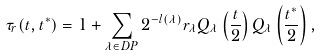Convert formula to latex. <formula><loc_0><loc_0><loc_500><loc_500>\tau _ { r } ( { t } , { t } ^ { * } ) = 1 + \sum _ { { \lambda } \in D P } 2 ^ { - l ( { \lambda } ) } r _ { \lambda } Q _ { \lambda } \left ( \frac { t } { 2 } \right ) Q _ { \lambda } \left ( \frac { { t } ^ { * } } { 2 } \right ) ,</formula> 